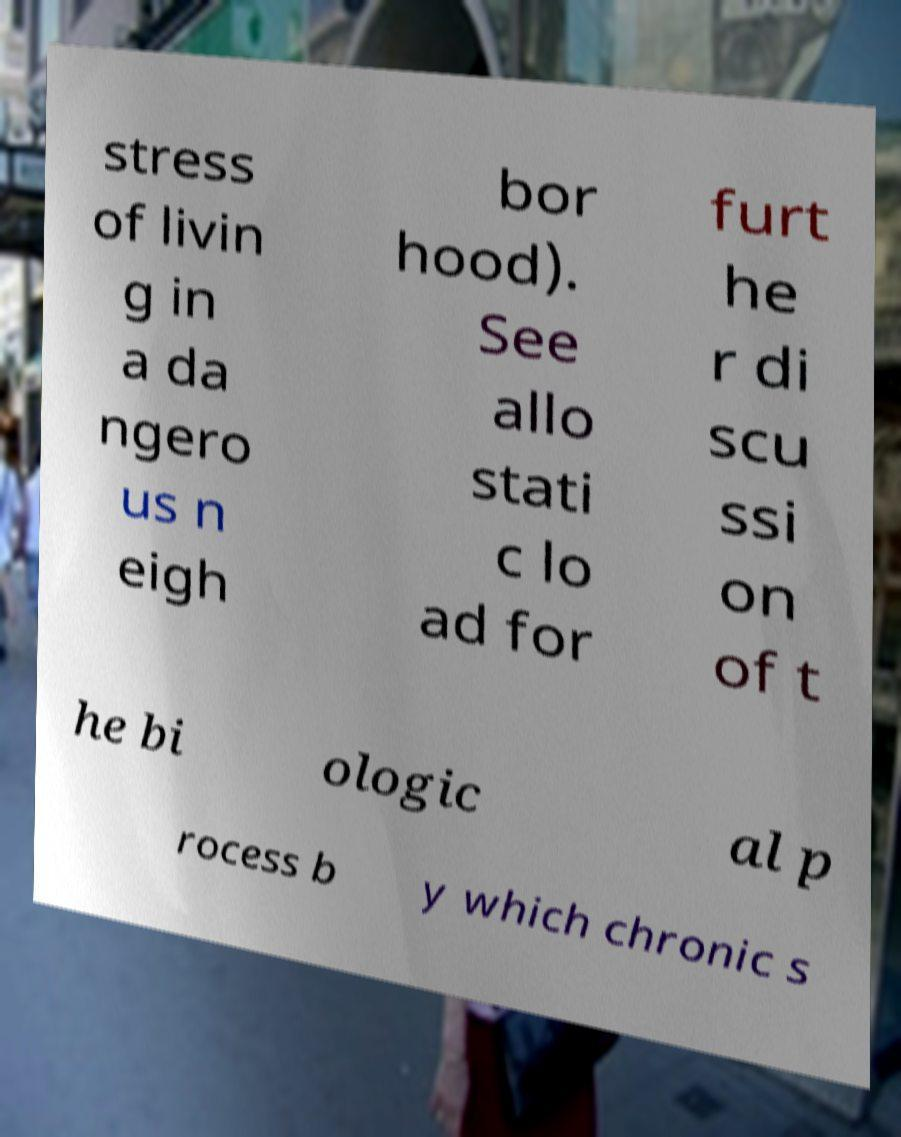Could you assist in decoding the text presented in this image and type it out clearly? stress of livin g in a da ngero us n eigh bor hood). See allo stati c lo ad for furt he r di scu ssi on of t he bi ologic al p rocess b y which chronic s 